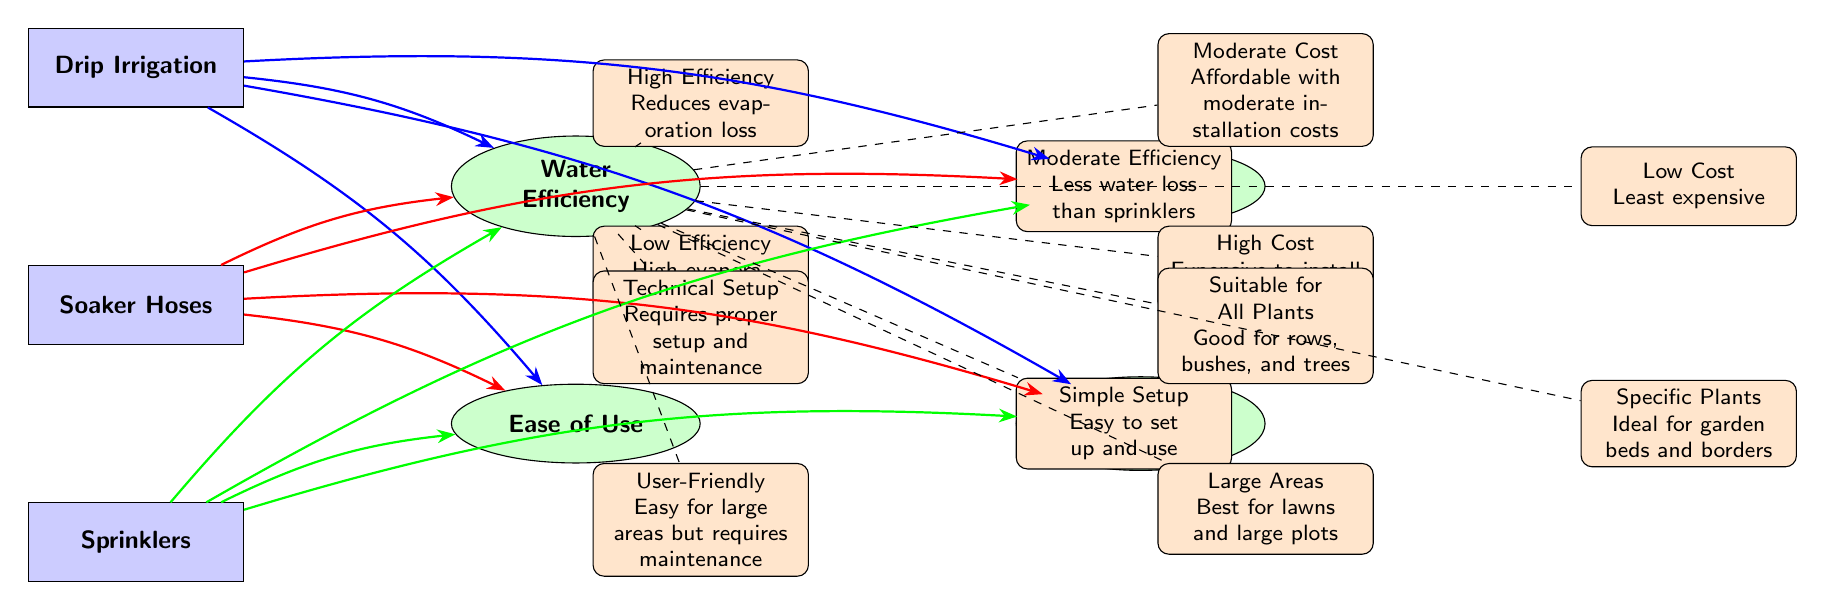What are the water efficiency levels of the irrigation methods? The diagram provides a summary of water efficiency levels for each irrigation method. Drip irrigation has "High Efficiency," soaker hoses show "Moderate Efficiency," and sprinklers have "Low Efficiency."
Answer: High Efficiency, Moderate Efficiency, Low Efficiency Which irrigation method is the least expensive? Based on the diagram, it specifically states that soaker hoses have "Low Cost," indicating they are the least expensive irrigation method among the three.
Answer: Low Cost What type of plants is drip irrigation suitable for? Referring to the suitability criteria in the diagram, it indicates that drip irrigation is "Suitable for All Plants," meaning it can be used with various types of plants.
Answer: Suitable for All Plants Which irrigation method is suited for large areas? The diagram mentions that the suitability of sprinklers is "Best for lawns and large plots," indicating they are the best choice for larger areas.
Answer: Best for lawns and large plots How does the cost of drip irrigation compare to that of soaker hoses and sprinklers? From the cost criteria, drip irrigation has a "Moderate Cost," soaker hoses have "Low Cost," and sprinklers have "High Cost." Therefore, drip irrigation is more expensive than soaker hoses but less expensive than sprinklers.
Answer: Moderate Cost, Low Cost, High Cost Which method requires more technical setup? According to the ease of use criterion, the diagram points out drip irrigation requires "Technical Setup," while soaker hoses are easy to use, making it clear that drip irrigation has a higher demand for technical setup.
Answer: Technical Setup What is the primary efficiency drawback of sprinklers? The diagram explicitly states that sprinklers have "High evaporation and runoff," which indicates their primary efficiency drawback compared to the other methods.
Answer: High evaporation and runoff What irrigation method is described as having a simple setup? Within the ease of use criteria, soaker hoses are highlighted as having a "Simple Setup," which signifies they are the easiest to set up among the three methods.
Answer: Simple Setup 